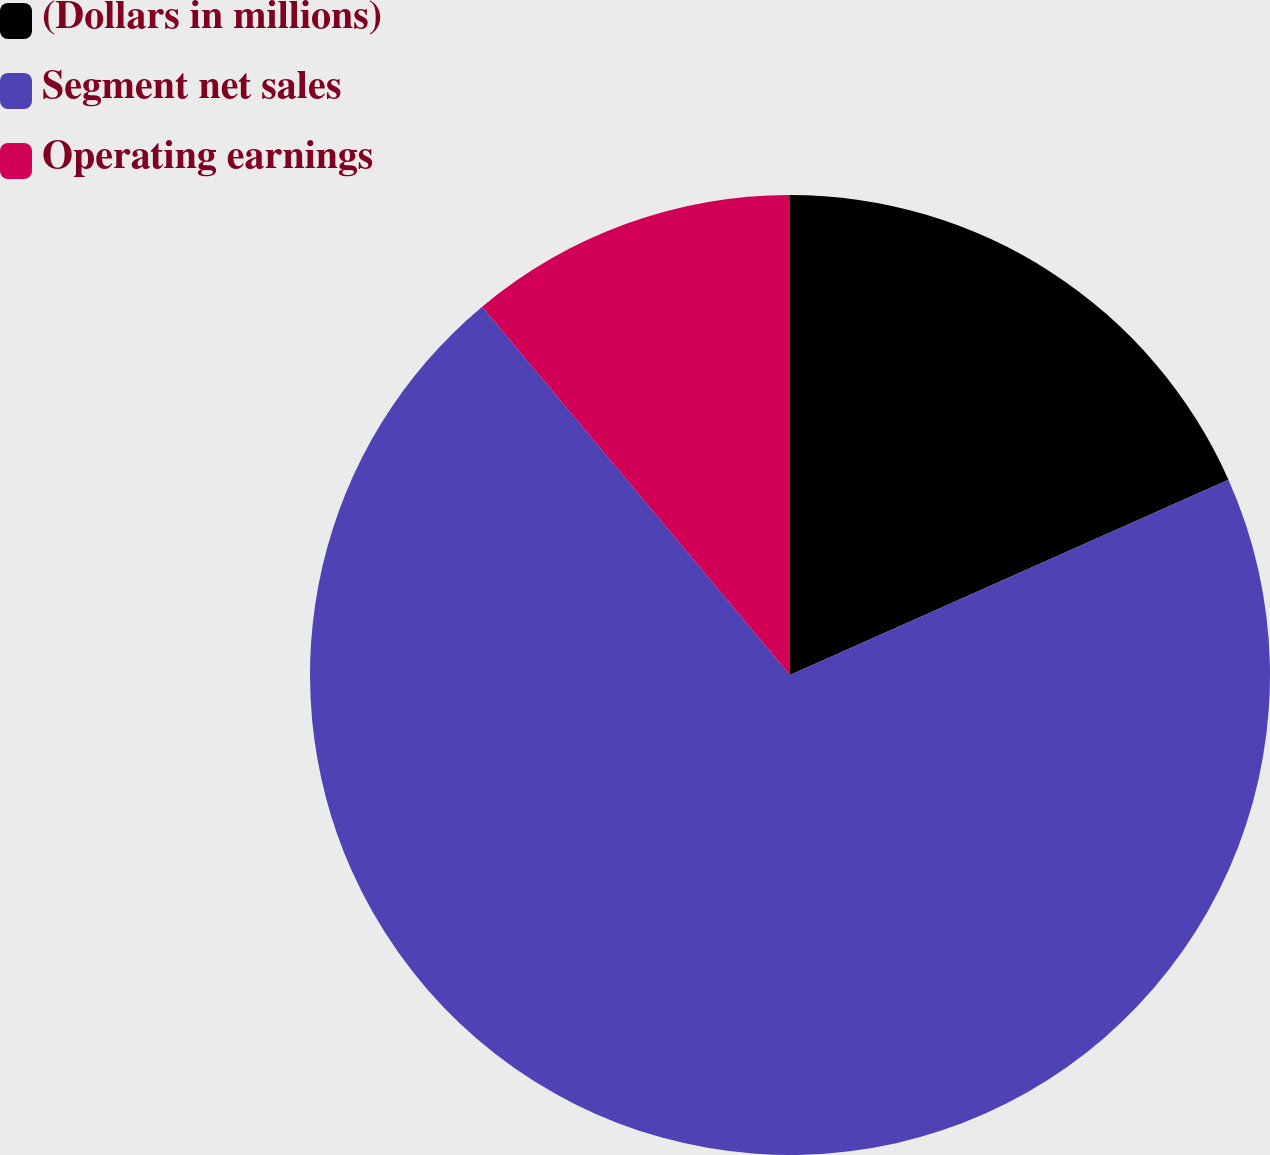Convert chart. <chart><loc_0><loc_0><loc_500><loc_500><pie_chart><fcel>(Dollars in millions)<fcel>Segment net sales<fcel>Operating earnings<nl><fcel>18.33%<fcel>70.59%<fcel>11.08%<nl></chart> 